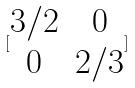<formula> <loc_0><loc_0><loc_500><loc_500>[ \begin{matrix} 3 / 2 & 0 \\ 0 & 2 / 3 \end{matrix} ]</formula> 